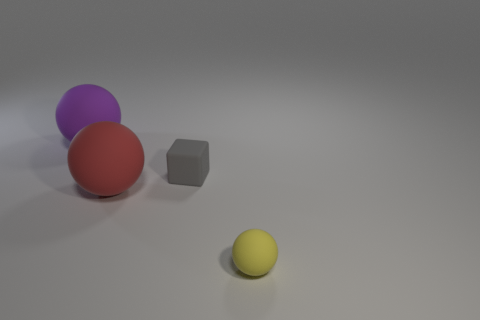What time of day does the lighting in the picture suggest? The image features a neutral and soft lighting with diffuse shadows, which is suggestive of an overcast day or artificial lighting often used in indoor photography or rendering. 